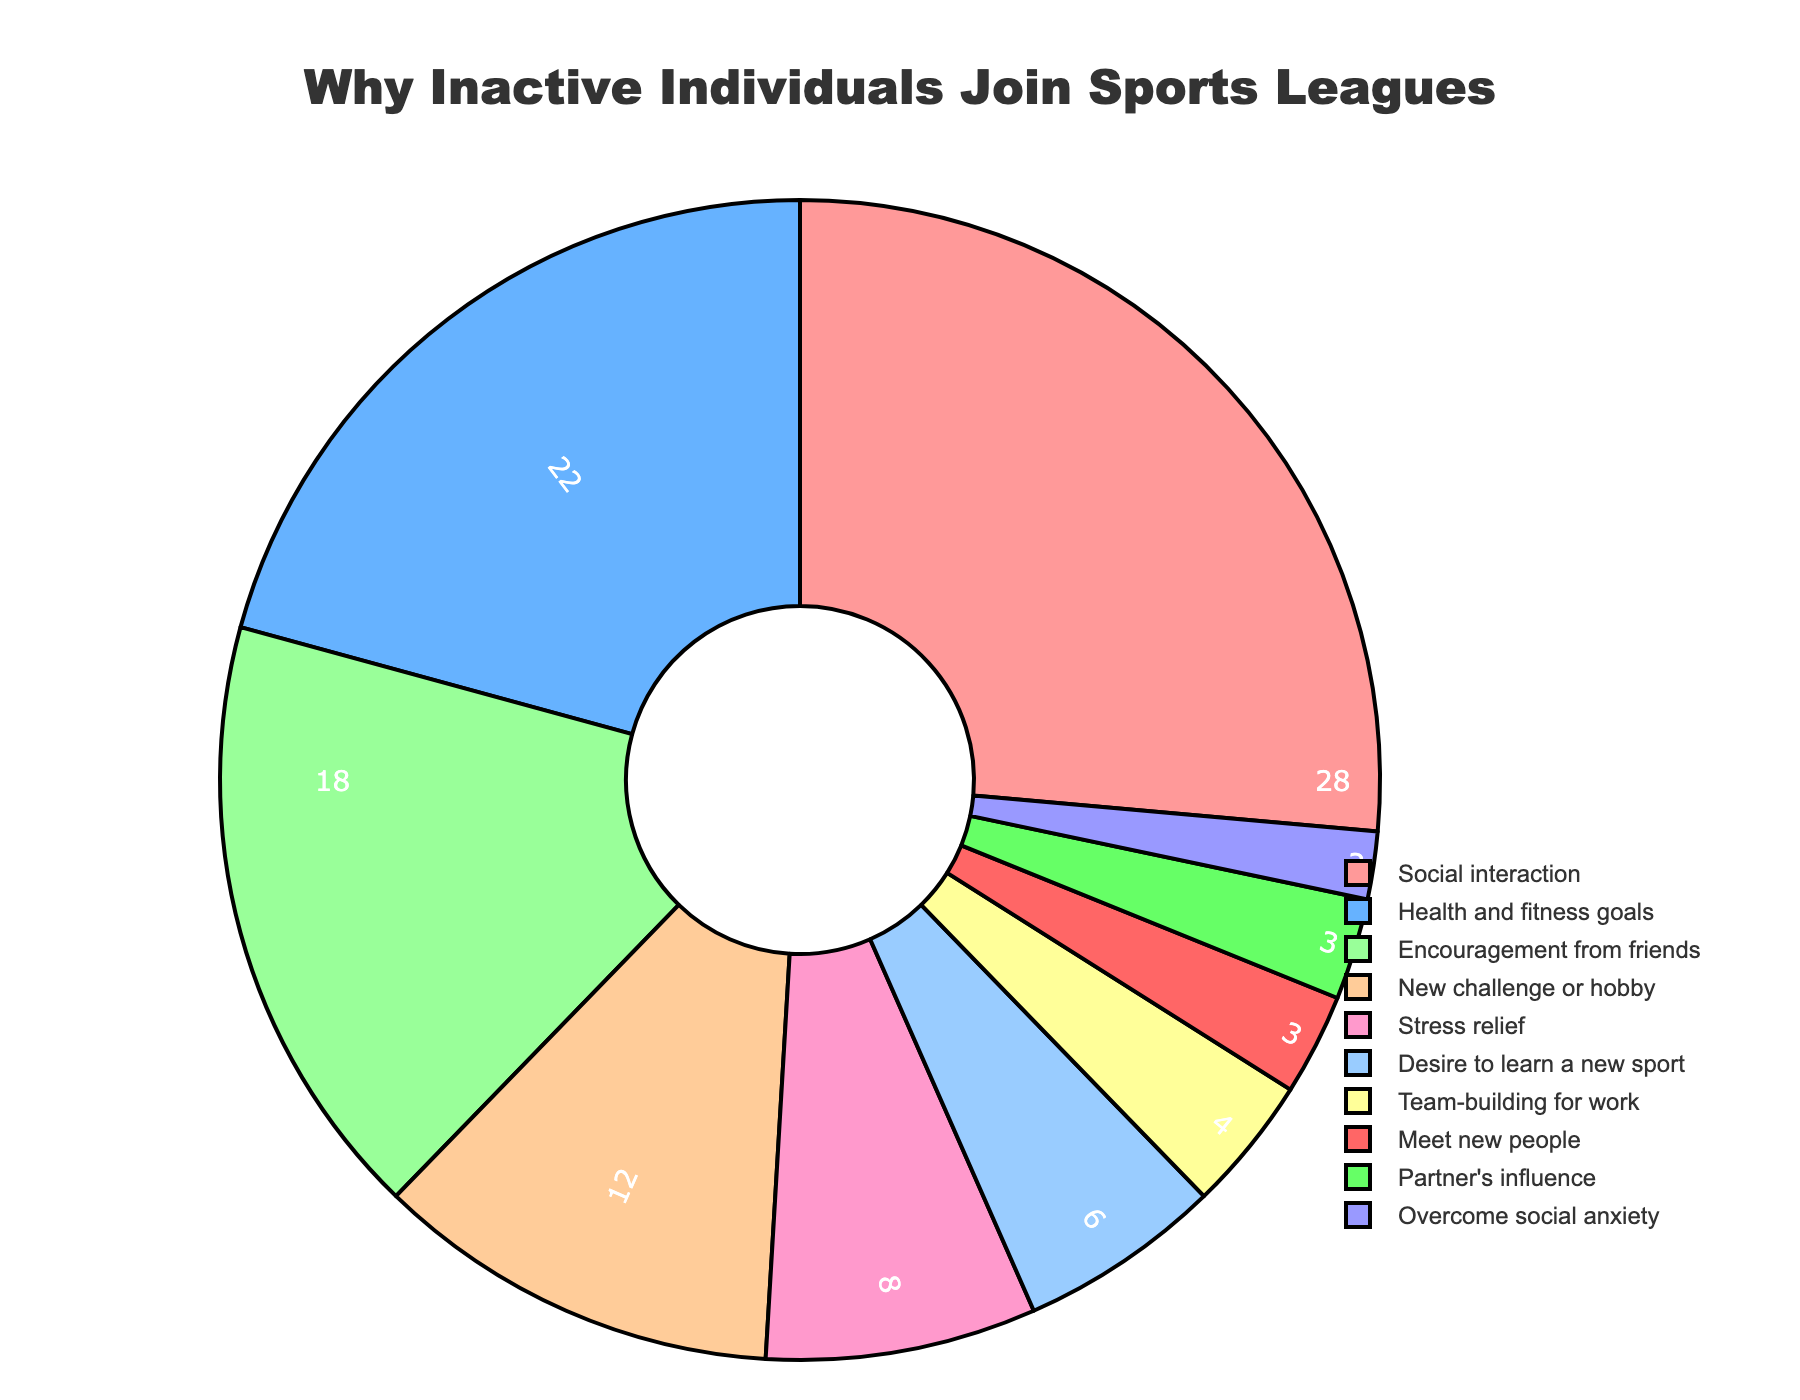Which reason has the highest percentage of individuals joining recreational sports leagues? The pie chart shows the distribution of reasons with their respective percentages. 'Social interaction' has the largest segment.
Answer: Social interaction What is the combined percentage of individuals joining for 'Health and fitness goals' and 'Stress relief'? Add the percentages for 'Health and fitness goals' (22%) and 'Stress relief' (8%).
Answer: 30% Which has a lower percentage: 'Encouragement from friends' or 'Meet new people'? Compare the percentages of 'Encouragement from friends' (18%) and 'Meet new people' (3%).
Answer: Meet new people What is the total percentage for the top three reasons? Retrieve the top three percentages: 'Social interaction' (28%), 'Health and fitness goals' (22%), and 'Encouragement from friends' (18%) and then sum them up.
Answer: 68% What is the percentage difference between 'New challenge or hobby' and 'Team-building for work’? Subtract the percentage of 'Team-building for work' (4%) from 'New challenge or hobby' (12%).
Answer: 8% What percentage of individuals join specifically because of a partner or to overcome social anxiety? Add the percentages of 'Partner's influence' (3%) and 'Overcome social anxiety' (2%).
Answer: 5% Which reason has the smallest percentage of individuals joining? The pie chart displays 'Overcome social anxiety' at the smallest segment with 2%.
Answer: Overcome social anxiety How does the percentage of people joining due to 'Health and fitness goals' compare to 'Social interaction'? Compare the percentages: 'Health and fitness goals' is 22% and 'Social interaction' is 28%.
Answer: Less What is the percentage of people joining for reasons that are related to social reasons? Add percentages for 'Social interaction' (28%), 'Encouragement from friends' (18%), 'Meet new people' (3%), and 'Partner's influence' (3%).
Answer: 52% What percentage more people join for 'Health and fitness goals' than 'Desire to learn a new sport'? Subtract 'Desire to learn a new sport' (6%) from 'Health and fitness goals' (22%).
Answer: 16% 